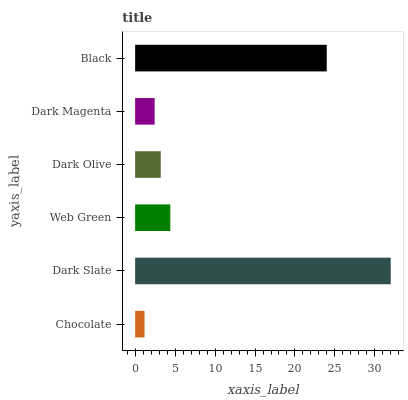Is Chocolate the minimum?
Answer yes or no. Yes. Is Dark Slate the maximum?
Answer yes or no. Yes. Is Web Green the minimum?
Answer yes or no. No. Is Web Green the maximum?
Answer yes or no. No. Is Dark Slate greater than Web Green?
Answer yes or no. Yes. Is Web Green less than Dark Slate?
Answer yes or no. Yes. Is Web Green greater than Dark Slate?
Answer yes or no. No. Is Dark Slate less than Web Green?
Answer yes or no. No. Is Web Green the high median?
Answer yes or no. Yes. Is Dark Olive the low median?
Answer yes or no. Yes. Is Chocolate the high median?
Answer yes or no. No. Is Chocolate the low median?
Answer yes or no. No. 